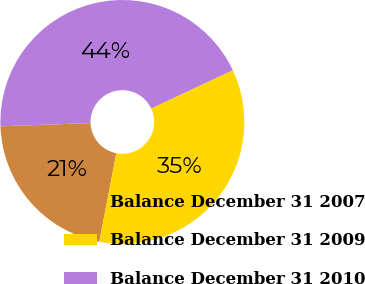Convert chart to OTSL. <chart><loc_0><loc_0><loc_500><loc_500><pie_chart><fcel>Balance December 31 2007<fcel>Balance December 31 2009<fcel>Balance December 31 2010<nl><fcel>21.41%<fcel>35.0%<fcel>43.59%<nl></chart> 